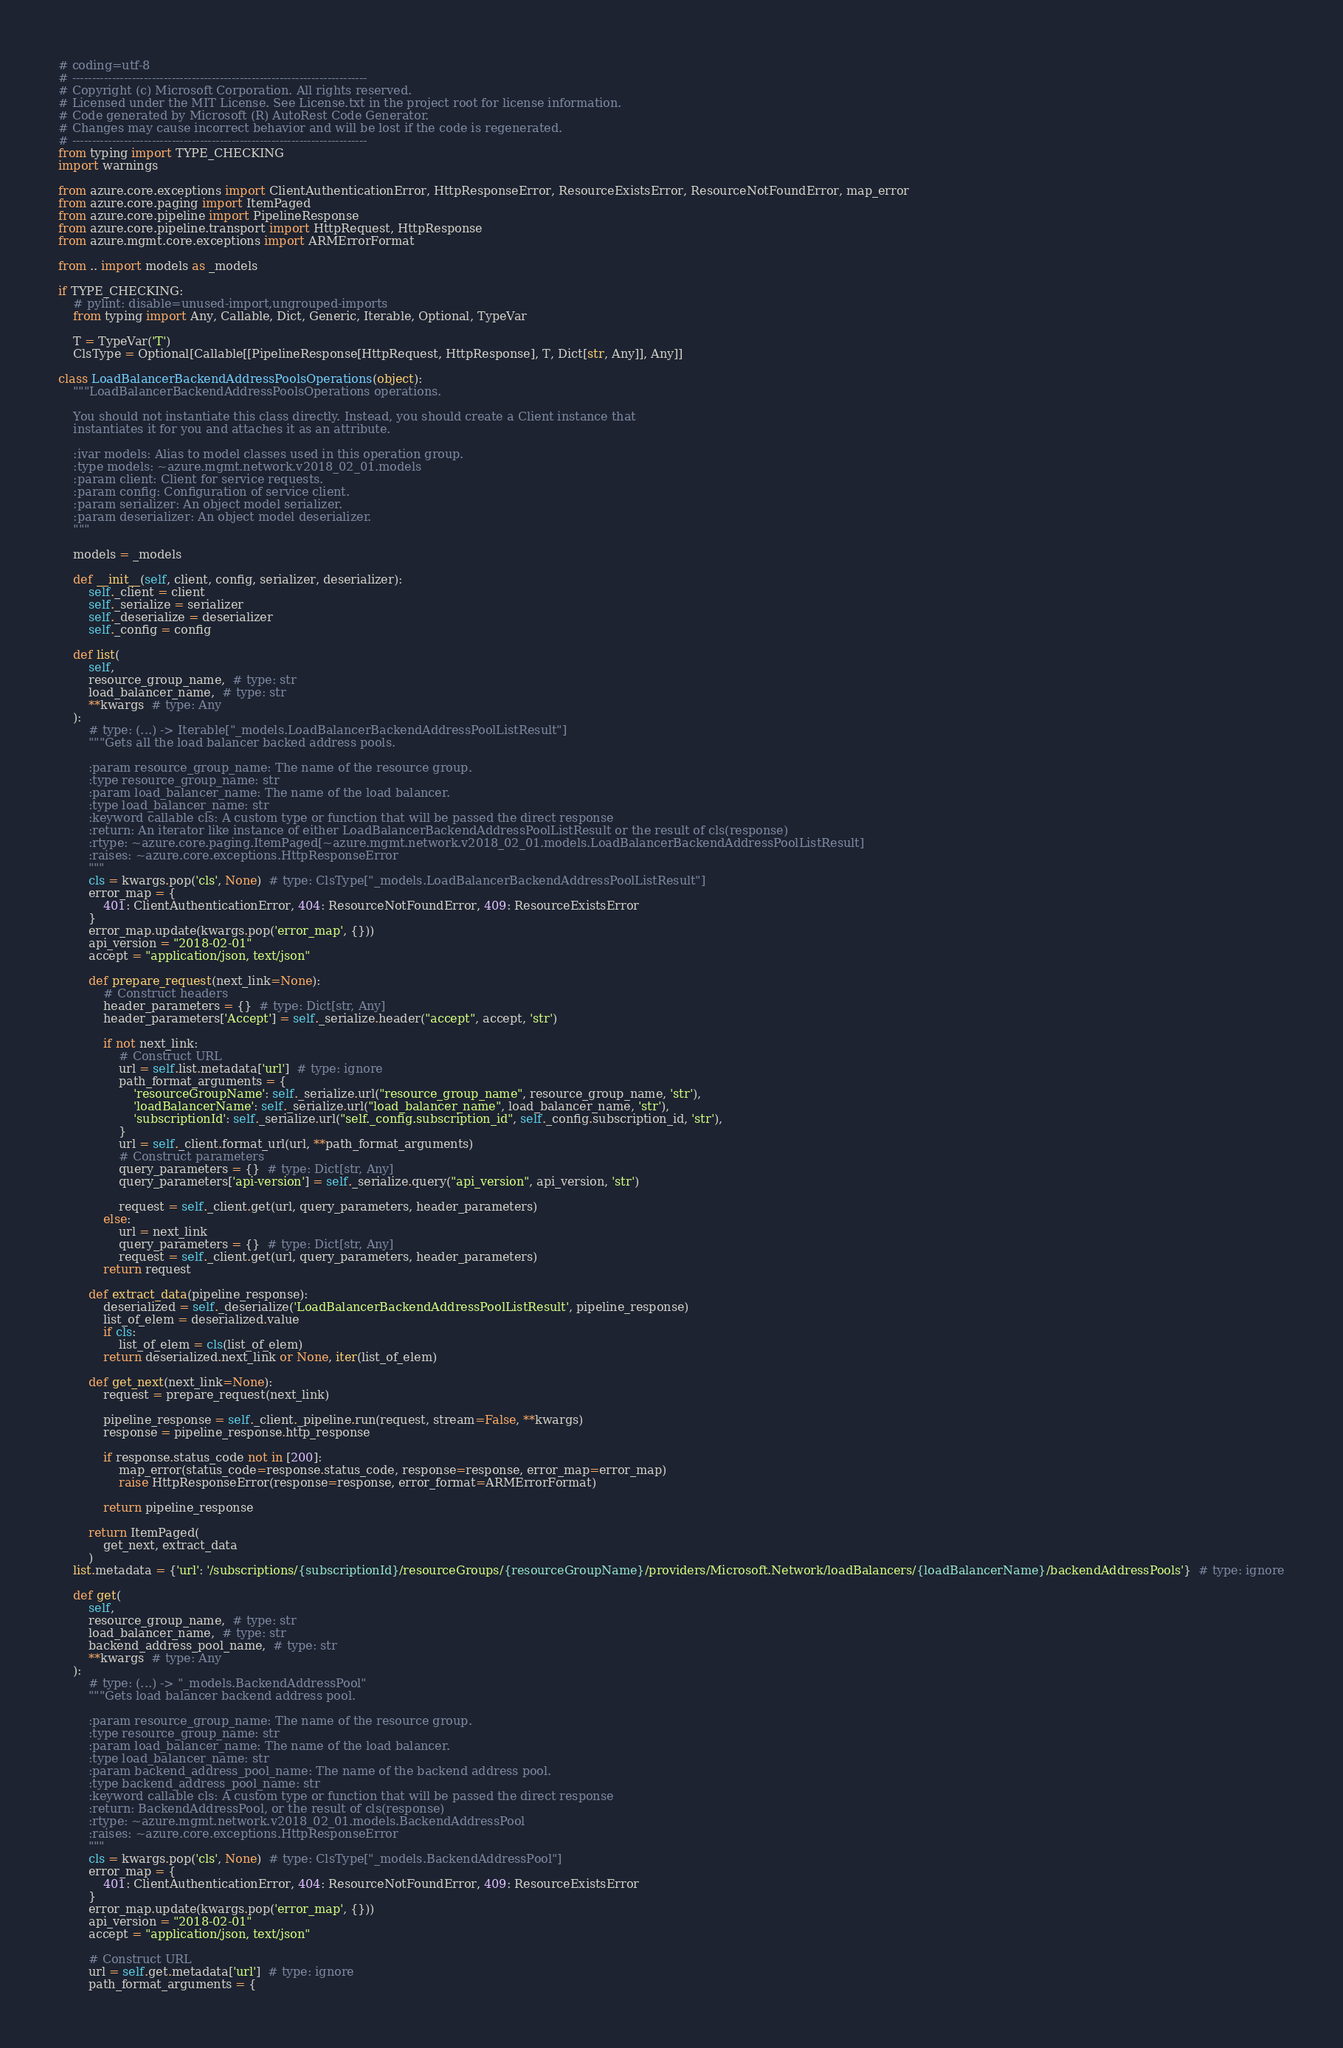Convert code to text. <code><loc_0><loc_0><loc_500><loc_500><_Python_># coding=utf-8
# --------------------------------------------------------------------------
# Copyright (c) Microsoft Corporation. All rights reserved.
# Licensed under the MIT License. See License.txt in the project root for license information.
# Code generated by Microsoft (R) AutoRest Code Generator.
# Changes may cause incorrect behavior and will be lost if the code is regenerated.
# --------------------------------------------------------------------------
from typing import TYPE_CHECKING
import warnings

from azure.core.exceptions import ClientAuthenticationError, HttpResponseError, ResourceExistsError, ResourceNotFoundError, map_error
from azure.core.paging import ItemPaged
from azure.core.pipeline import PipelineResponse
from azure.core.pipeline.transport import HttpRequest, HttpResponse
from azure.mgmt.core.exceptions import ARMErrorFormat

from .. import models as _models

if TYPE_CHECKING:
    # pylint: disable=unused-import,ungrouped-imports
    from typing import Any, Callable, Dict, Generic, Iterable, Optional, TypeVar

    T = TypeVar('T')
    ClsType = Optional[Callable[[PipelineResponse[HttpRequest, HttpResponse], T, Dict[str, Any]], Any]]

class LoadBalancerBackendAddressPoolsOperations(object):
    """LoadBalancerBackendAddressPoolsOperations operations.

    You should not instantiate this class directly. Instead, you should create a Client instance that
    instantiates it for you and attaches it as an attribute.

    :ivar models: Alias to model classes used in this operation group.
    :type models: ~azure.mgmt.network.v2018_02_01.models
    :param client: Client for service requests.
    :param config: Configuration of service client.
    :param serializer: An object model serializer.
    :param deserializer: An object model deserializer.
    """

    models = _models

    def __init__(self, client, config, serializer, deserializer):
        self._client = client
        self._serialize = serializer
        self._deserialize = deserializer
        self._config = config

    def list(
        self,
        resource_group_name,  # type: str
        load_balancer_name,  # type: str
        **kwargs  # type: Any
    ):
        # type: (...) -> Iterable["_models.LoadBalancerBackendAddressPoolListResult"]
        """Gets all the load balancer backed address pools.

        :param resource_group_name: The name of the resource group.
        :type resource_group_name: str
        :param load_balancer_name: The name of the load balancer.
        :type load_balancer_name: str
        :keyword callable cls: A custom type or function that will be passed the direct response
        :return: An iterator like instance of either LoadBalancerBackendAddressPoolListResult or the result of cls(response)
        :rtype: ~azure.core.paging.ItemPaged[~azure.mgmt.network.v2018_02_01.models.LoadBalancerBackendAddressPoolListResult]
        :raises: ~azure.core.exceptions.HttpResponseError
        """
        cls = kwargs.pop('cls', None)  # type: ClsType["_models.LoadBalancerBackendAddressPoolListResult"]
        error_map = {
            401: ClientAuthenticationError, 404: ResourceNotFoundError, 409: ResourceExistsError
        }
        error_map.update(kwargs.pop('error_map', {}))
        api_version = "2018-02-01"
        accept = "application/json, text/json"

        def prepare_request(next_link=None):
            # Construct headers
            header_parameters = {}  # type: Dict[str, Any]
            header_parameters['Accept'] = self._serialize.header("accept", accept, 'str')

            if not next_link:
                # Construct URL
                url = self.list.metadata['url']  # type: ignore
                path_format_arguments = {
                    'resourceGroupName': self._serialize.url("resource_group_name", resource_group_name, 'str'),
                    'loadBalancerName': self._serialize.url("load_balancer_name", load_balancer_name, 'str'),
                    'subscriptionId': self._serialize.url("self._config.subscription_id", self._config.subscription_id, 'str'),
                }
                url = self._client.format_url(url, **path_format_arguments)
                # Construct parameters
                query_parameters = {}  # type: Dict[str, Any]
                query_parameters['api-version'] = self._serialize.query("api_version", api_version, 'str')

                request = self._client.get(url, query_parameters, header_parameters)
            else:
                url = next_link
                query_parameters = {}  # type: Dict[str, Any]
                request = self._client.get(url, query_parameters, header_parameters)
            return request

        def extract_data(pipeline_response):
            deserialized = self._deserialize('LoadBalancerBackendAddressPoolListResult', pipeline_response)
            list_of_elem = deserialized.value
            if cls:
                list_of_elem = cls(list_of_elem)
            return deserialized.next_link or None, iter(list_of_elem)

        def get_next(next_link=None):
            request = prepare_request(next_link)

            pipeline_response = self._client._pipeline.run(request, stream=False, **kwargs)
            response = pipeline_response.http_response

            if response.status_code not in [200]:
                map_error(status_code=response.status_code, response=response, error_map=error_map)
                raise HttpResponseError(response=response, error_format=ARMErrorFormat)

            return pipeline_response

        return ItemPaged(
            get_next, extract_data
        )
    list.metadata = {'url': '/subscriptions/{subscriptionId}/resourceGroups/{resourceGroupName}/providers/Microsoft.Network/loadBalancers/{loadBalancerName}/backendAddressPools'}  # type: ignore

    def get(
        self,
        resource_group_name,  # type: str
        load_balancer_name,  # type: str
        backend_address_pool_name,  # type: str
        **kwargs  # type: Any
    ):
        # type: (...) -> "_models.BackendAddressPool"
        """Gets load balancer backend address pool.

        :param resource_group_name: The name of the resource group.
        :type resource_group_name: str
        :param load_balancer_name: The name of the load balancer.
        :type load_balancer_name: str
        :param backend_address_pool_name: The name of the backend address pool.
        :type backend_address_pool_name: str
        :keyword callable cls: A custom type or function that will be passed the direct response
        :return: BackendAddressPool, or the result of cls(response)
        :rtype: ~azure.mgmt.network.v2018_02_01.models.BackendAddressPool
        :raises: ~azure.core.exceptions.HttpResponseError
        """
        cls = kwargs.pop('cls', None)  # type: ClsType["_models.BackendAddressPool"]
        error_map = {
            401: ClientAuthenticationError, 404: ResourceNotFoundError, 409: ResourceExistsError
        }
        error_map.update(kwargs.pop('error_map', {}))
        api_version = "2018-02-01"
        accept = "application/json, text/json"

        # Construct URL
        url = self.get.metadata['url']  # type: ignore
        path_format_arguments = {</code> 